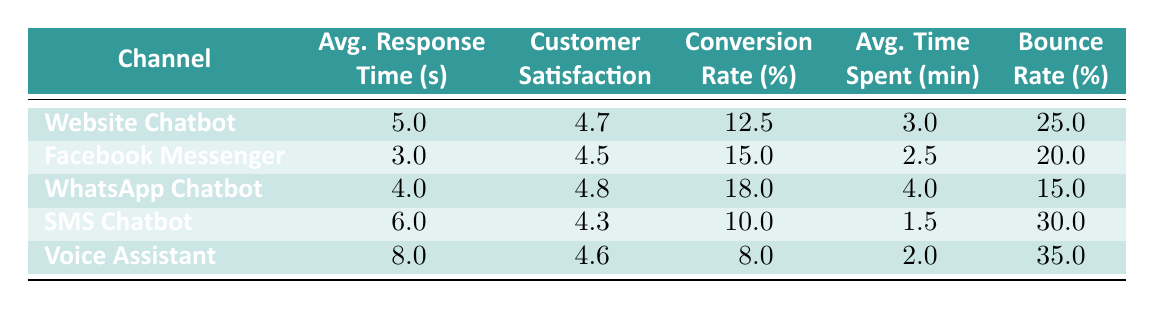What's the average response time for the Facebook Messenger channel? The average response time for the Facebook Messenger channel is explicitly provided in the table as 3 seconds.
Answer: 3 seconds Which channel has the highest customer satisfaction score? By examining the customer satisfaction scores in the table, WhatsApp Chatbot has the highest score of 4.8.
Answer: WhatsApp Chatbot Calculate the difference in conversion rates between the Website Chatbot and the WhatsApp Chatbot. The conversion rate for the Website Chatbot is 12.5%, while for the WhatsApp Chatbot it is 18.0%. The difference is 18.0 - 12.5 = 5.5.
Answer: 5.5 Is the average time spent on the SMS Chatbot higher than on the Voice Assistant? The SMS Chatbot has an average time spent of 1.5 minutes, while the Voice Assistant has an average of 2.0 minutes. Since 1.5 is less than 2.0, the statement is false.
Answer: No Which channel has the lowest bounce rate, and what is that percentage? The bounce rate percentage for each channel is listed in the table. The lowest score is 15% for WhatsApp Chatbot.
Answer: WhatsApp Chatbot, 15% What is the average customer satisfaction score across all channels? To find the average, sum all customer satisfaction scores: (4.7 + 4.5 + 4.8 + 4.3 + 4.6) = 22.9. Then divide by the number of channels (5): 22.9 / 5 = 4.58.
Answer: 4.58 Does the Facebook Messenger channel have a higher conversion rate than the SMS Chatbot? The conversion rate for Facebook Messenger is 15.0%, whereas for SMS Chatbot it is 10.0%. Since 15.0 is greater than 10.0, the statement is true.
Answer: Yes Identify the channel with the longest average response time. The average response times are: Website Chatbot (5s), Facebook Messenger (3s), WhatsApp Chatbot (4s), SMS Chatbot (6s), and Voice Assistant (8s). The longest time is 8 seconds for the Voice Assistant.
Answer: Voice Assistant, 8 seconds 